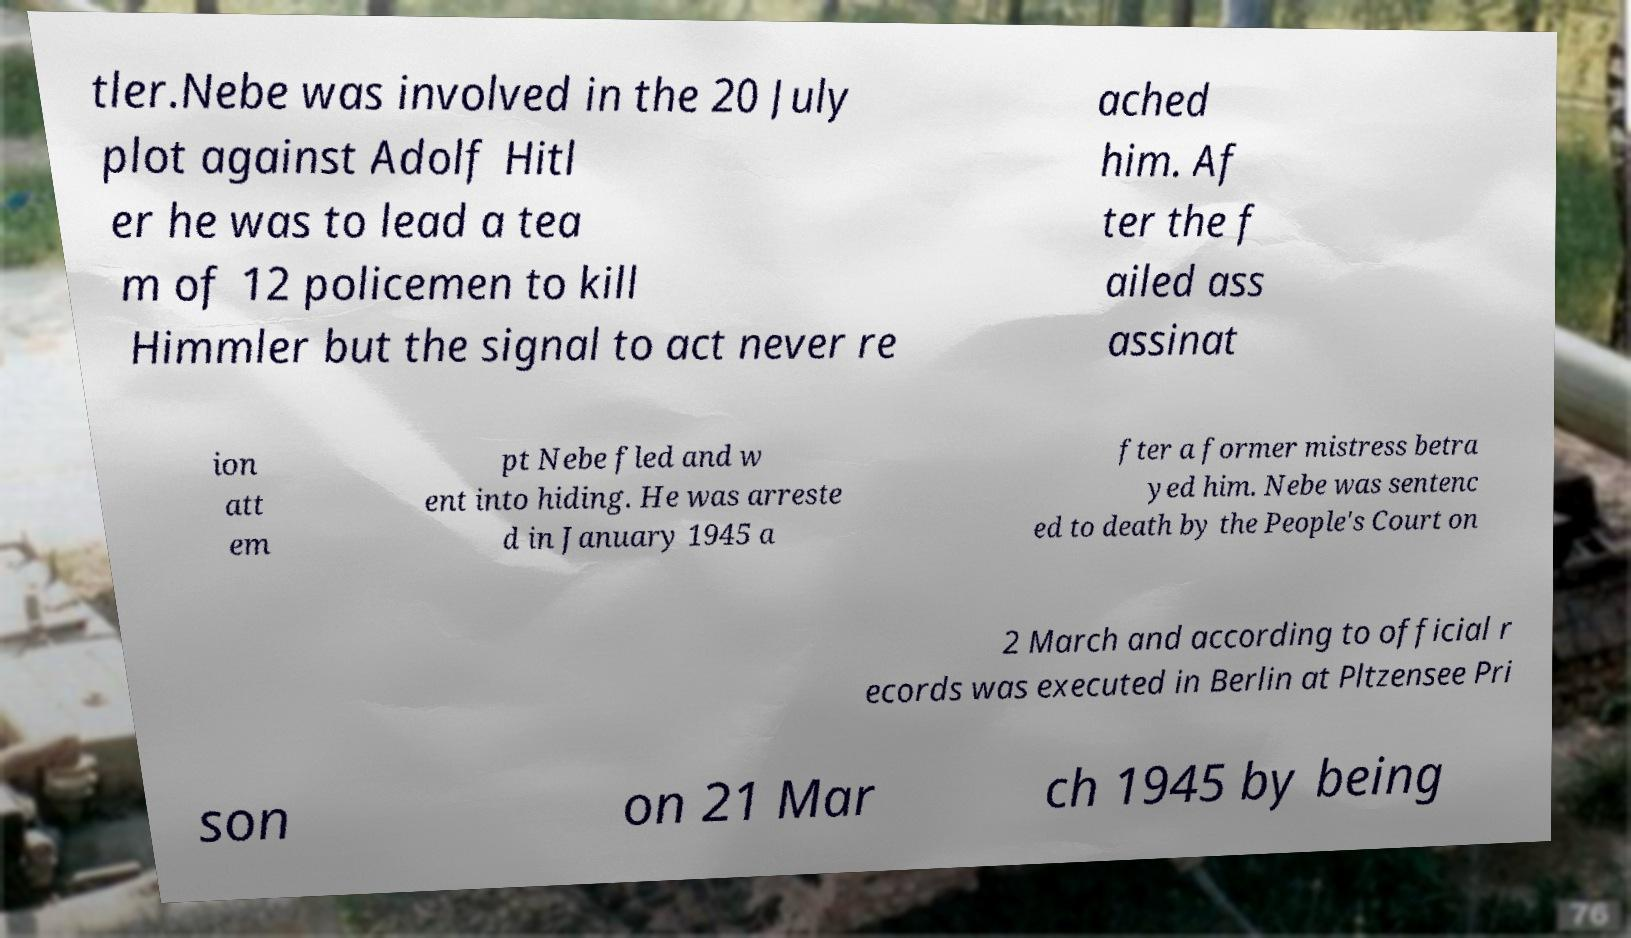Can you accurately transcribe the text from the provided image for me? tler.Nebe was involved in the 20 July plot against Adolf Hitl er he was to lead a tea m of 12 policemen to kill Himmler but the signal to act never re ached him. Af ter the f ailed ass assinat ion att em pt Nebe fled and w ent into hiding. He was arreste d in January 1945 a fter a former mistress betra yed him. Nebe was sentenc ed to death by the People's Court on 2 March and according to official r ecords was executed in Berlin at Pltzensee Pri son on 21 Mar ch 1945 by being 